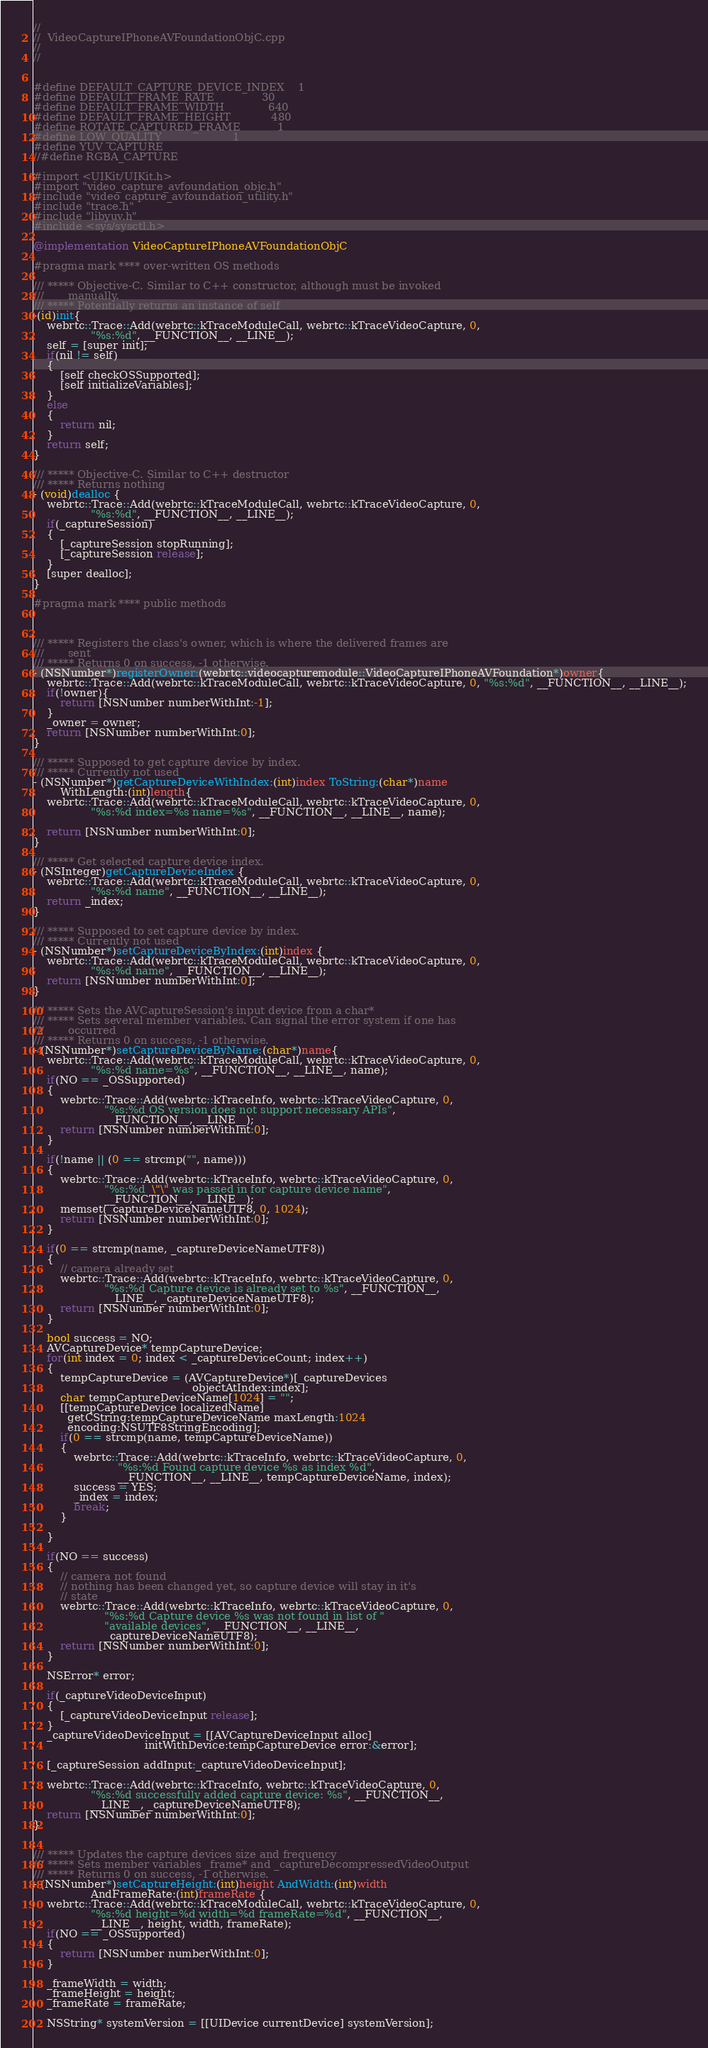<code> <loc_0><loc_0><loc_500><loc_500><_ObjectiveC_>//
//  VideoCaptureIPhoneAVFoundationObjC.cpp
//
//


#define DEFAULT_CAPTURE_DEVICE_INDEX    1
#define DEFAULT_FRAME_RATE              30
#define DEFAULT_FRAME_WIDTH             640
#define DEFAULT_FRAME_HEIGHT            480
#define ROTATE_CAPTURED_FRAME           1
#define LOW_QUALITY                     1
#define YUV_CAPTURE
//#define RGBA_CAPTURE

#import <UIKit/UIKit.h>
#import "video_capture_avfoundation_objc.h"
#include "video_capture_avfoundation_utility.h"
#include "trace.h"
#include "libyuv.h"
#include <sys/sysctl.h>

@implementation VideoCaptureIPhoneAVFoundationObjC

#pragma mark **** over-written OS methods

/// ***** Objective-C. Similar to C++ constructor, although must be invoked
///       manually.
/// ***** Potentially returns an instance of self
-(id)init{
    webrtc::Trace::Add(webrtc::kTraceModuleCall, webrtc::kTraceVideoCapture, 0,
                 "%s:%d", __FUNCTION__, __LINE__);
    self = [super init];
    if(nil != self)
    {
        [self checkOSSupported];
        [self initializeVariables];
    }
    else
    {
        return nil;
    }
    return self;
}

/// ***** Objective-C. Similar to C++ destructor
/// ***** Returns nothing
- (void)dealloc {
    webrtc::Trace::Add(webrtc::kTraceModuleCall, webrtc::kTraceVideoCapture, 0,
                 "%s:%d", __FUNCTION__, __LINE__);
    if(_captureSession)
    {
        [_captureSession stopRunning];
        [_captureSession release];
    }
    [super dealloc];
}

#pragma mark **** public methods



/// ***** Registers the class's owner, which is where the delivered frames are
///       sent
/// ***** Returns 0 on success, -1 otherwise.
- (NSNumber*)registerOwner:(webrtc::videocapturemodule::VideoCaptureIPhoneAVFoundation*)owner{
    webrtc::Trace::Add(webrtc::kTraceModuleCall, webrtc::kTraceVideoCapture, 0, "%s:%d", __FUNCTION__, __LINE__);
    if(!owner){
        return [NSNumber numberWithInt:-1];
    }
    _owner = owner;
    return [NSNumber numberWithInt:0];
}

/// ***** Supposed to get capture device by index.
/// ***** Currently not used
- (NSNumber*)getCaptureDeviceWithIndex:(int)index ToString:(char*)name
        WithLength:(int)length{
    webrtc::Trace::Add(webrtc::kTraceModuleCall, webrtc::kTraceVideoCapture, 0,
                 "%s:%d index=%s name=%s", __FUNCTION__, __LINE__, name);

    return [NSNumber numberWithInt:0];
}

/// ***** Get selected capture device index.
- (NSInteger)getCaptureDeviceIndex {
    webrtc::Trace::Add(webrtc::kTraceModuleCall, webrtc::kTraceVideoCapture, 0,
                 "%s:%d name", __FUNCTION__, __LINE__);
    return _index;
}

/// ***** Supposed to set capture device by index.
/// ***** Currently not used
- (NSNumber*)setCaptureDeviceByIndex:(int)index {
    webrtc::Trace::Add(webrtc::kTraceModuleCall, webrtc::kTraceVideoCapture, 0,
                 "%s:%d name", __FUNCTION__, __LINE__);
    return [NSNumber numberWithInt:0];
}

/// ***** Sets the AVCaptureSession's input device from a char*
/// ***** Sets several member variables. Can signal the error system if one has
///       occurred
/// ***** Returns 0 on success, -1 otherwise.
- (NSNumber*)setCaptureDeviceByName:(char*)name{
    webrtc::Trace::Add(webrtc::kTraceModuleCall, webrtc::kTraceVideoCapture, 0,
                 "%s:%d name=%s", __FUNCTION__, __LINE__, name);
    if(NO == _OSSupported)
    {
        webrtc::Trace::Add(webrtc::kTraceInfo, webrtc::kTraceVideoCapture, 0,
                     "%s:%d OS version does not support necessary APIs",
                     __FUNCTION__, __LINE__);
        return [NSNumber numberWithInt:0];
    }

    if(!name || (0 == strcmp("", name)))
    {
        webrtc::Trace::Add(webrtc::kTraceInfo, webrtc::kTraceVideoCapture, 0,
                     "%s:%d  \"\" was passed in for capture device name",
                     __FUNCTION__, __LINE__);
        memset(_captureDeviceNameUTF8, 0, 1024);
        return [NSNumber numberWithInt:0];
    }

    if(0 == strcmp(name, _captureDeviceNameUTF8))
    {
        // camera already set
        webrtc::Trace::Add(webrtc::kTraceInfo, webrtc::kTraceVideoCapture, 0,
                     "%s:%d Capture device is already set to %s", __FUNCTION__,
                     __LINE__, _captureDeviceNameUTF8);
        return [NSNumber numberWithInt:0];
    }

    bool success = NO;
    AVCaptureDevice* tempCaptureDevice;
    for(int index = 0; index < _captureDeviceCount; index++)
    {
        tempCaptureDevice = (AVCaptureDevice*)[_captureDevices
                                               objectAtIndex:index];
        char tempCaptureDeviceName[1024] = "";
        [[tempCaptureDevice localizedName]
          getCString:tempCaptureDeviceName maxLength:1024
          encoding:NSUTF8StringEncoding];
        if(0 == strcmp(name, tempCaptureDeviceName))
        {
            webrtc::Trace::Add(webrtc::kTraceInfo, webrtc::kTraceVideoCapture, 0,
                         "%s:%d Found capture device %s as index %d",
                         __FUNCTION__, __LINE__, tempCaptureDeviceName, index);
            success = YES;
            _index = index;
            break;
        }

    }

    if(NO == success)
    {
        // camera not found
        // nothing has been changed yet, so capture device will stay in it's
        // state
        webrtc::Trace::Add(webrtc::kTraceInfo, webrtc::kTraceVideoCapture, 0,
                     "%s:%d Capture device %s was not found in list of "
                     "available devices", __FUNCTION__, __LINE__,
                     _captureDeviceNameUTF8);
        return [NSNumber numberWithInt:0];
    }

    NSError* error;

    if(_captureVideoDeviceInput)
    {
        [_captureVideoDeviceInput release];
    }
    _captureVideoDeviceInput = [[AVCaptureDeviceInput alloc]
                                 initWithDevice:tempCaptureDevice error:&error];

    [_captureSession addInput:_captureVideoDeviceInput];

    webrtc::Trace::Add(webrtc::kTraceInfo, webrtc::kTraceVideoCapture, 0,
                 "%s:%d successfully added capture device: %s", __FUNCTION__,
                 __LINE__, _captureDeviceNameUTF8);
    return [NSNumber numberWithInt:0];
}


/// ***** Updates the capture devices size and frequency
/// ***** Sets member variables _frame* and _captureDecompressedVideoOutput
/// ***** Returns 0 on success, -1 otherwise.
- (NSNumber*)setCaptureHeight:(int)height AndWidth:(int)width
                 AndFrameRate:(int)frameRate {
    webrtc::Trace::Add(webrtc::kTraceModuleCall, webrtc::kTraceVideoCapture, 0,
                 "%s:%d height=%d width=%d frameRate=%d", __FUNCTION__,
                 __LINE__, height, width, frameRate);
    if(NO == _OSSupported)
    {
        return [NSNumber numberWithInt:0];
    }

    _frameWidth = width;
    _frameHeight = height;
    _frameRate = frameRate;

    NSString* systemVersion = [[UIDevice currentDevice] systemVersion];</code> 